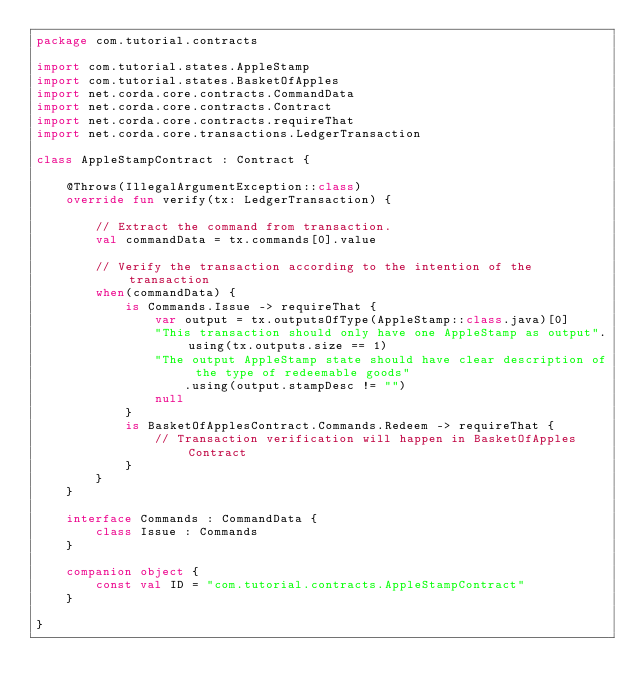Convert code to text. <code><loc_0><loc_0><loc_500><loc_500><_Kotlin_>package com.tutorial.contracts

import com.tutorial.states.AppleStamp
import com.tutorial.states.BasketOfApples
import net.corda.core.contracts.CommandData
import net.corda.core.contracts.Contract
import net.corda.core.contracts.requireThat
import net.corda.core.transactions.LedgerTransaction

class AppleStampContract : Contract {

    @Throws(IllegalArgumentException::class)
    override fun verify(tx: LedgerTransaction) {

        // Extract the command from transaction.
        val commandData = tx.commands[0].value

        // Verify the transaction according to the intention of the transaction
        when(commandData) {
            is Commands.Issue -> requireThat {
                var output = tx.outputsOfType(AppleStamp::class.java)[0]
                "This transaction should only have one AppleStamp as output".using(tx.outputs.size == 1)
                "The output AppleStamp state should have clear description of the type of redeemable goods"
                    .using(output.stampDesc != "")
                null
            }
            is BasketOfApplesContract.Commands.Redeem -> requireThat {
                // Transaction verification will happen in BasketOfApples Contract
            }
        }
    }

    interface Commands : CommandData {
        class Issue : Commands
    }

    companion object {
        const val ID = "com.tutorial.contracts.AppleStampContract"
    }

}</code> 